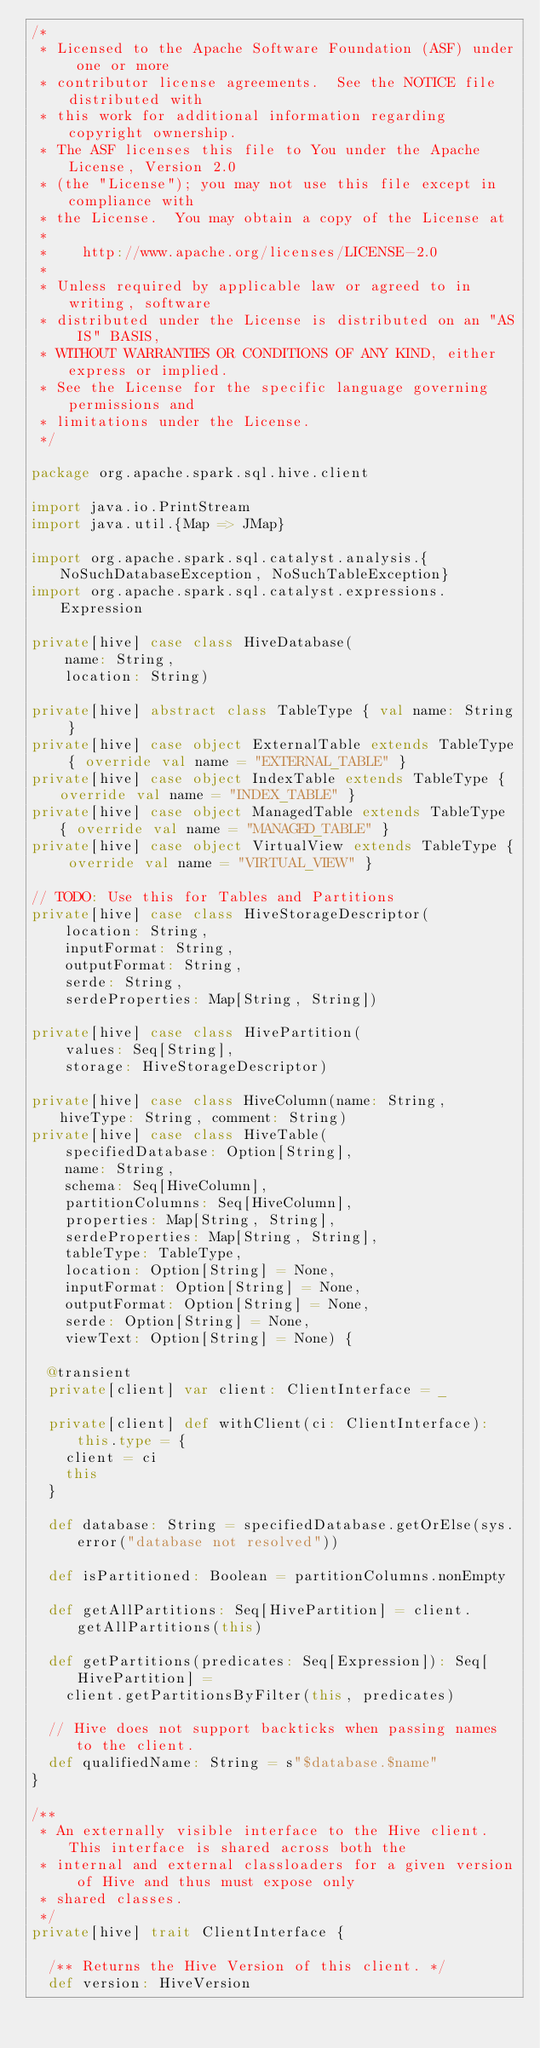Convert code to text. <code><loc_0><loc_0><loc_500><loc_500><_Scala_>/*
 * Licensed to the Apache Software Foundation (ASF) under one or more
 * contributor license agreements.  See the NOTICE file distributed with
 * this work for additional information regarding copyright ownership.
 * The ASF licenses this file to You under the Apache License, Version 2.0
 * (the "License"); you may not use this file except in compliance with
 * the License.  You may obtain a copy of the License at
 *
 *    http://www.apache.org/licenses/LICENSE-2.0
 *
 * Unless required by applicable law or agreed to in writing, software
 * distributed under the License is distributed on an "AS IS" BASIS,
 * WITHOUT WARRANTIES OR CONDITIONS OF ANY KIND, either express or implied.
 * See the License for the specific language governing permissions and
 * limitations under the License.
 */

package org.apache.spark.sql.hive.client

import java.io.PrintStream
import java.util.{Map => JMap}

import org.apache.spark.sql.catalyst.analysis.{NoSuchDatabaseException, NoSuchTableException}
import org.apache.spark.sql.catalyst.expressions.Expression

private[hive] case class HiveDatabase(
    name: String,
    location: String)

private[hive] abstract class TableType { val name: String }
private[hive] case object ExternalTable extends TableType { override val name = "EXTERNAL_TABLE" }
private[hive] case object IndexTable extends TableType { override val name = "INDEX_TABLE" }
private[hive] case object ManagedTable extends TableType { override val name = "MANAGED_TABLE" }
private[hive] case object VirtualView extends TableType { override val name = "VIRTUAL_VIEW" }

// TODO: Use this for Tables and Partitions
private[hive] case class HiveStorageDescriptor(
    location: String,
    inputFormat: String,
    outputFormat: String,
    serde: String,
    serdeProperties: Map[String, String])

private[hive] case class HivePartition(
    values: Seq[String],
    storage: HiveStorageDescriptor)

private[hive] case class HiveColumn(name: String, hiveType: String, comment: String)
private[hive] case class HiveTable(
    specifiedDatabase: Option[String],
    name: String,
    schema: Seq[HiveColumn],
    partitionColumns: Seq[HiveColumn],
    properties: Map[String, String],
    serdeProperties: Map[String, String],
    tableType: TableType,
    location: Option[String] = None,
    inputFormat: Option[String] = None,
    outputFormat: Option[String] = None,
    serde: Option[String] = None,
    viewText: Option[String] = None) {

  @transient
  private[client] var client: ClientInterface = _

  private[client] def withClient(ci: ClientInterface): this.type = {
    client = ci
    this
  }

  def database: String = specifiedDatabase.getOrElse(sys.error("database not resolved"))

  def isPartitioned: Boolean = partitionColumns.nonEmpty

  def getAllPartitions: Seq[HivePartition] = client.getAllPartitions(this)

  def getPartitions(predicates: Seq[Expression]): Seq[HivePartition] =
    client.getPartitionsByFilter(this, predicates)

  // Hive does not support backticks when passing names to the client.
  def qualifiedName: String = s"$database.$name"
}

/**
 * An externally visible interface to the Hive client.  This interface is shared across both the
 * internal and external classloaders for a given version of Hive and thus must expose only
 * shared classes.
 */
private[hive] trait ClientInterface {

  /** Returns the Hive Version of this client. */
  def version: HiveVersion
</code> 